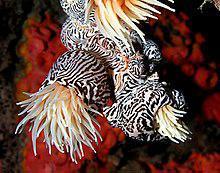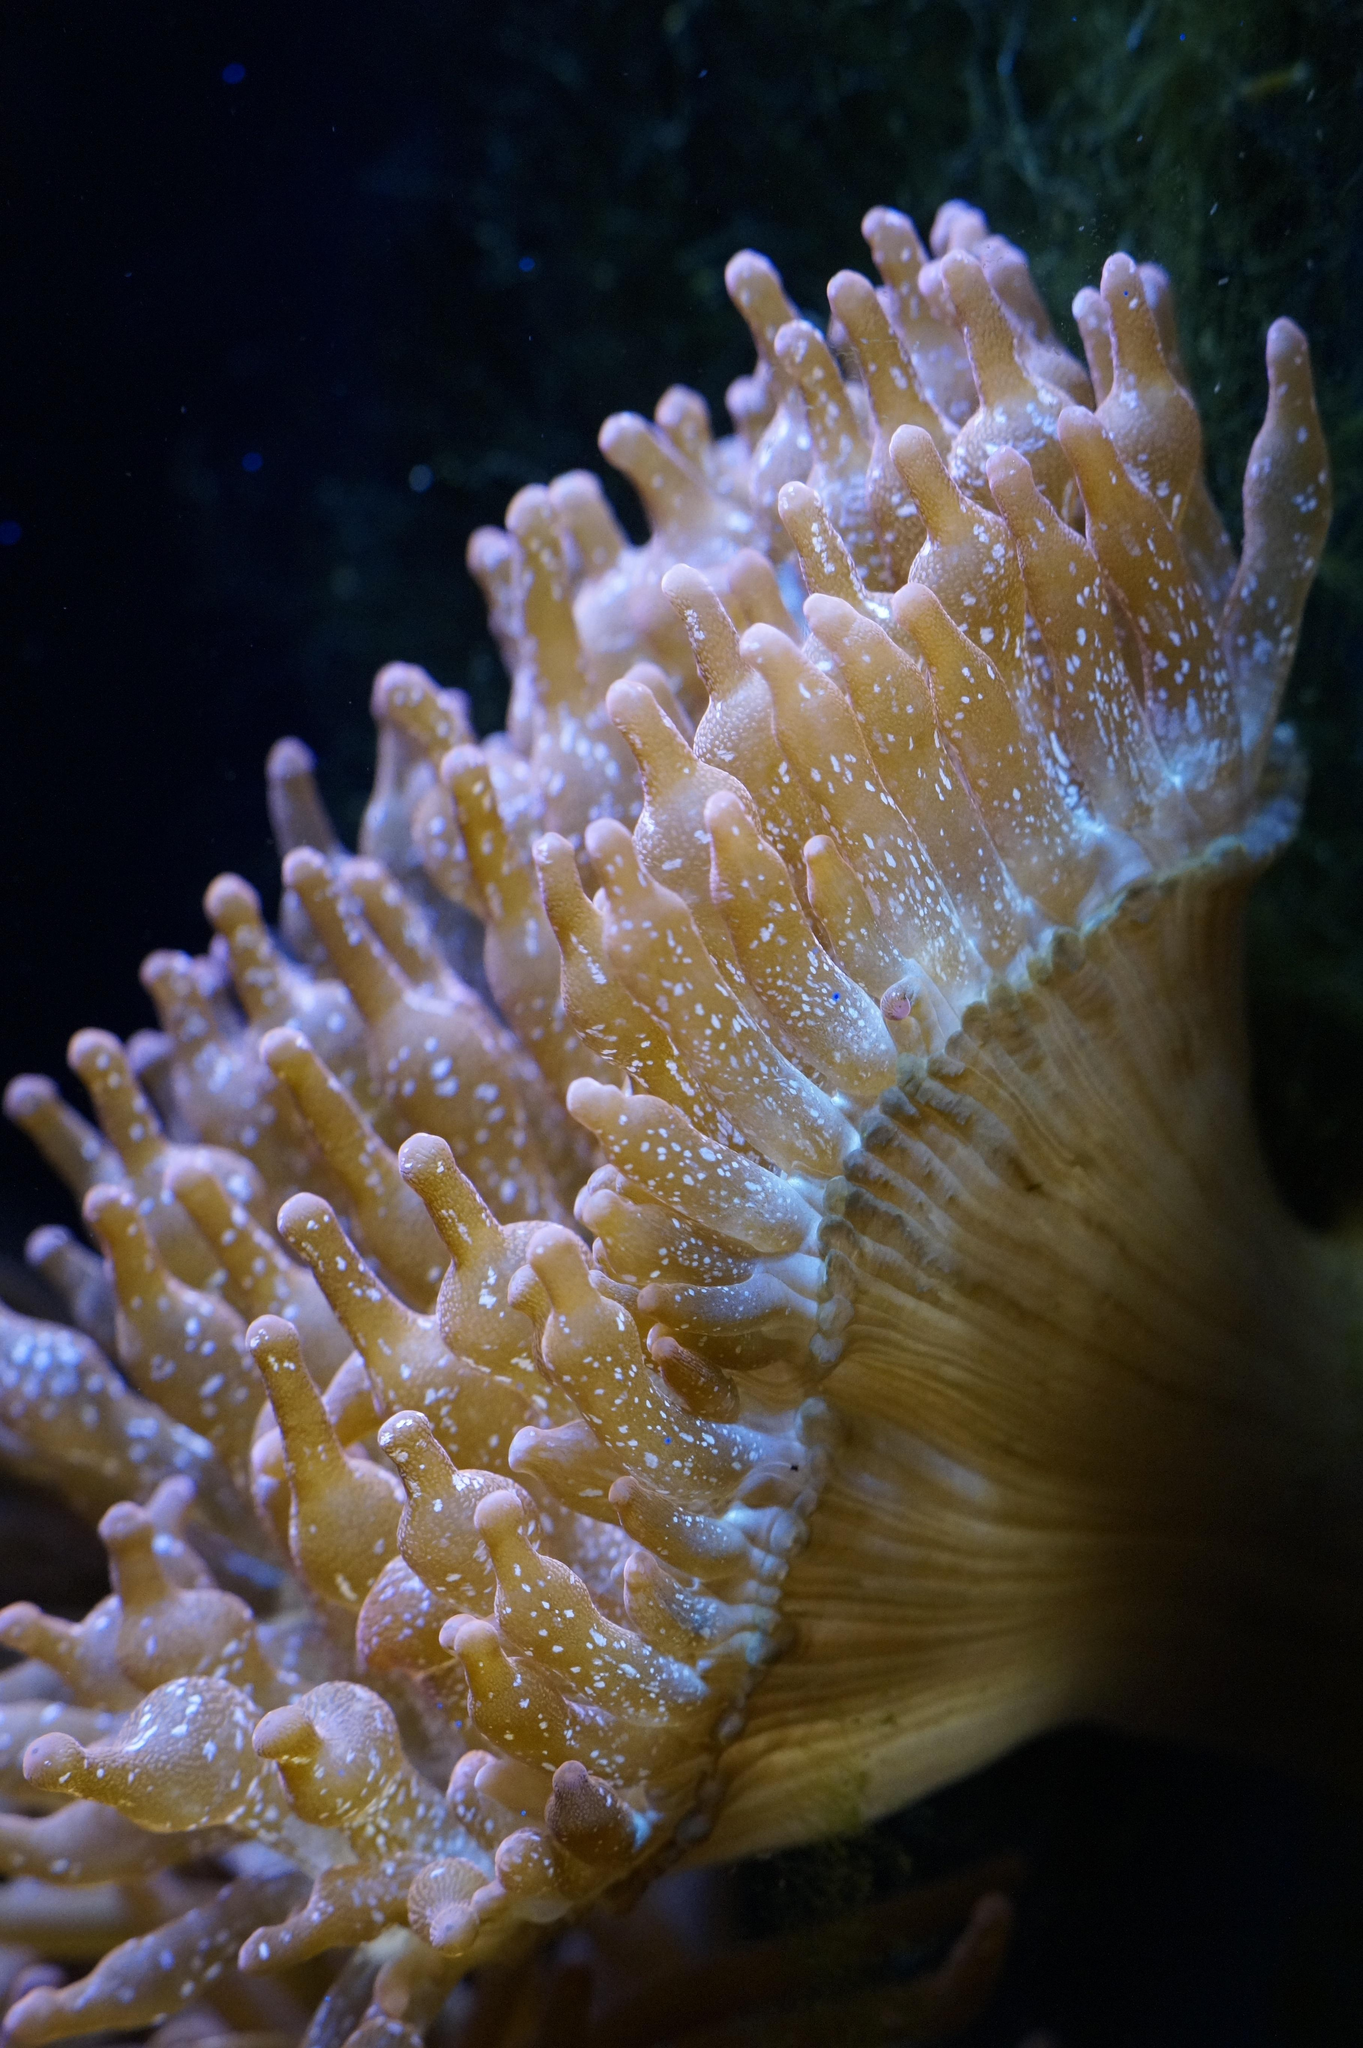The first image is the image on the left, the second image is the image on the right. Given the left and right images, does the statement "The anemones in the image on the left have black and white trunks" hold true? Answer yes or no. Yes. The first image is the image on the left, the second image is the image on the right. For the images shown, is this caption "An anemone image includes a black-and-white almost zebra-like pattern." true? Answer yes or no. Yes. 